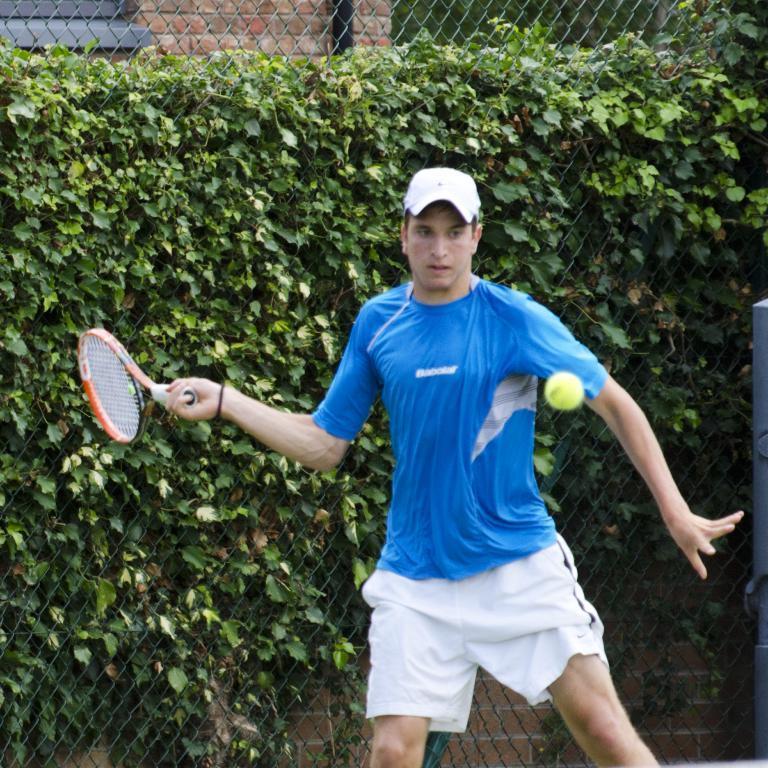Please provide a concise description of this image. In this picture we can see man wore blue color T-Shirt, cap holding tennis racket in his hand and trying to hit the ball and the background we can see tree, net. 